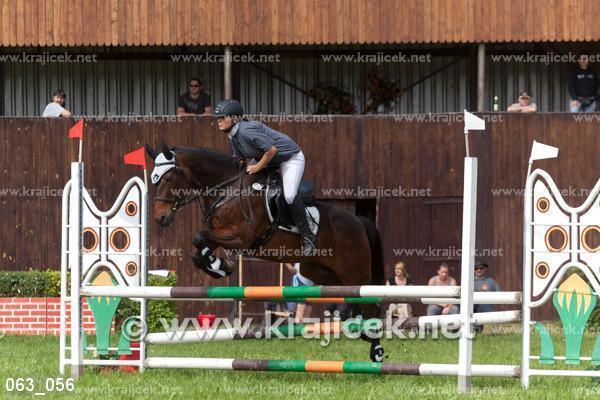Which bar is the horse meant to pass over?
Indicate the correct response and explain using: 'Answer: answer
Rationale: rationale.'
Options: Top bar, right vertical, left vertical, bottom. Answer: top bar.
Rationale: The goal of the sport is to jump over the bar without knocking any off. 